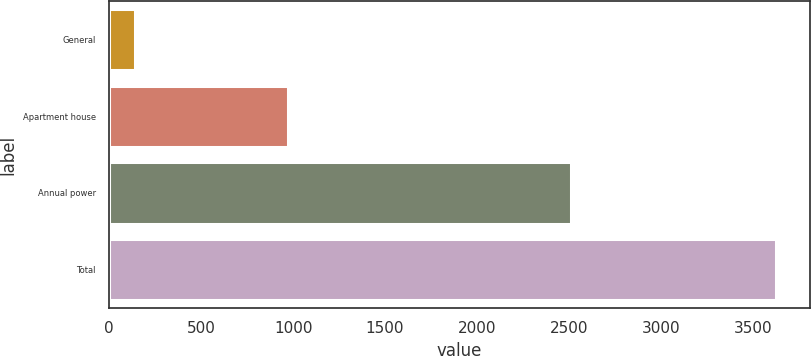Convert chart. <chart><loc_0><loc_0><loc_500><loc_500><bar_chart><fcel>General<fcel>Apartment house<fcel>Annual power<fcel>Total<nl><fcel>140<fcel>974<fcel>2513<fcel>3627<nl></chart> 